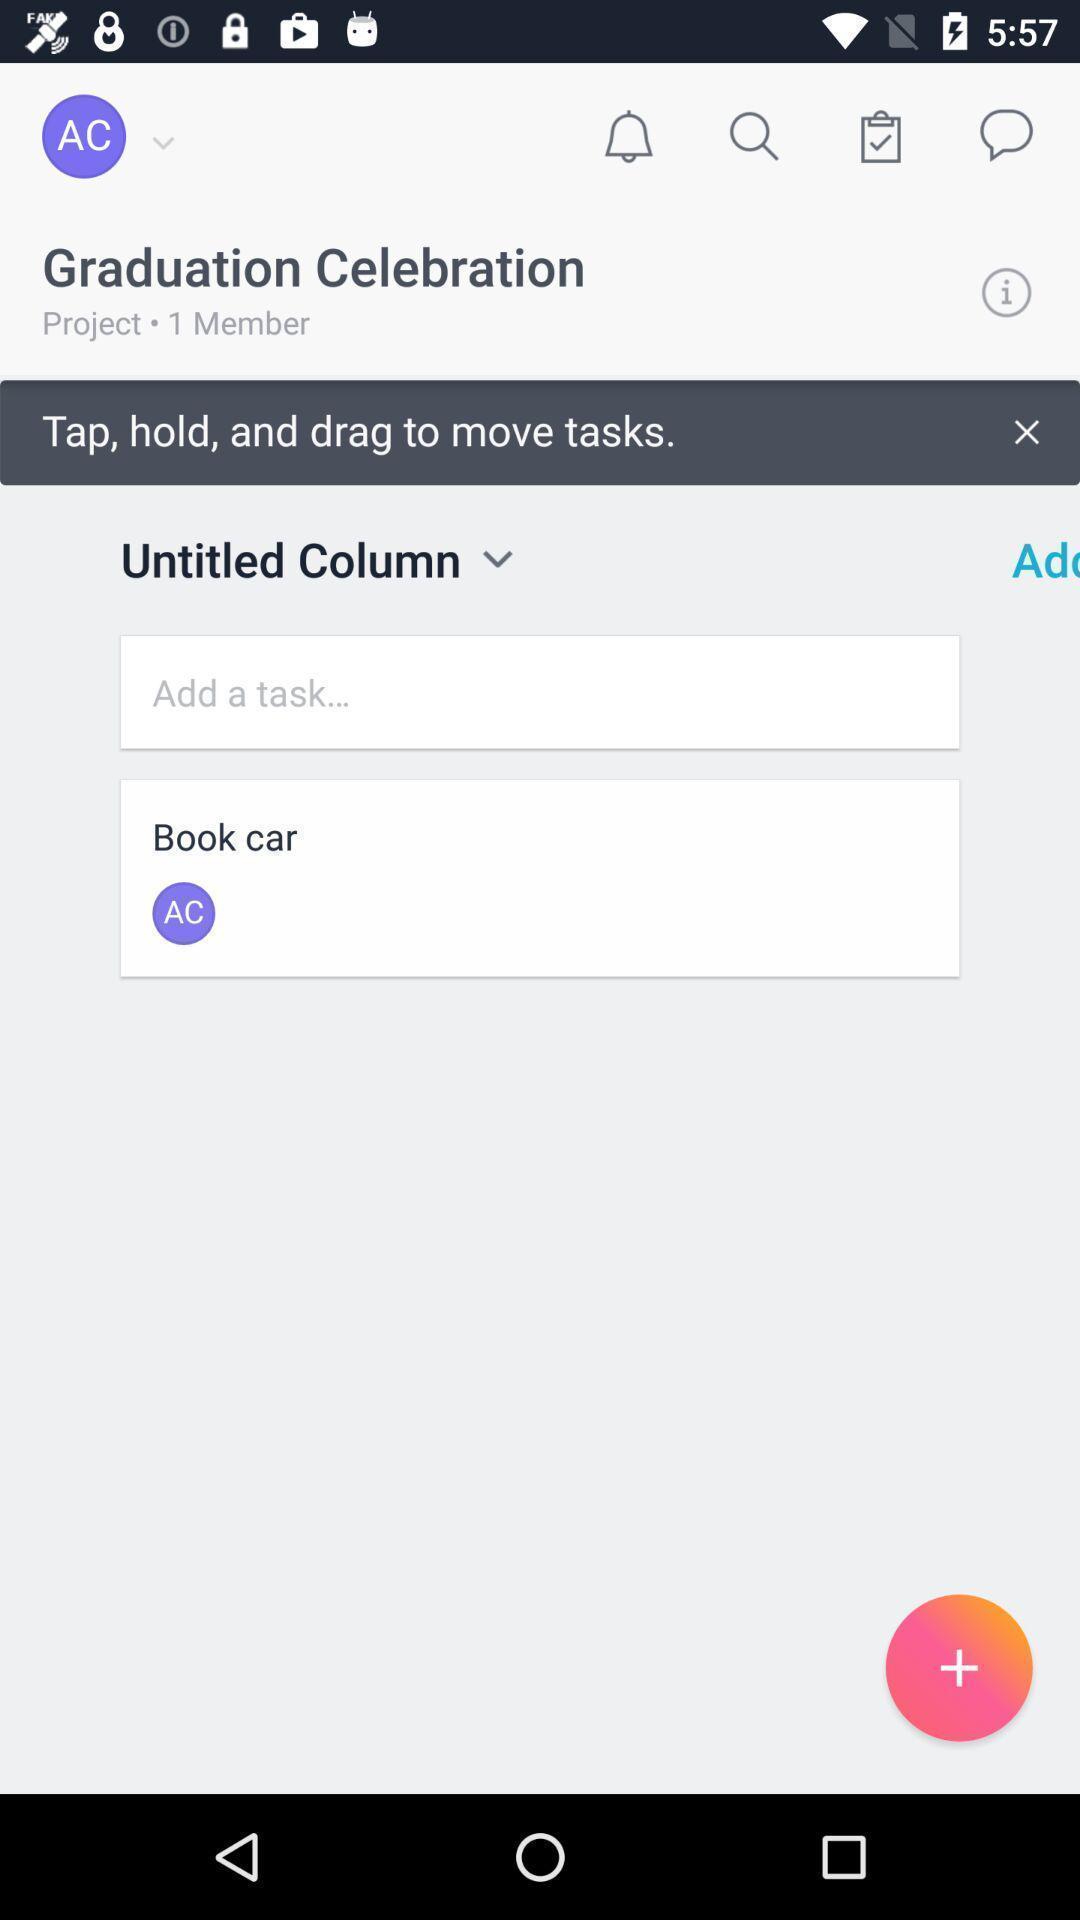Describe the visual elements of this screenshot. Screen shows update tasks in an alert app. 